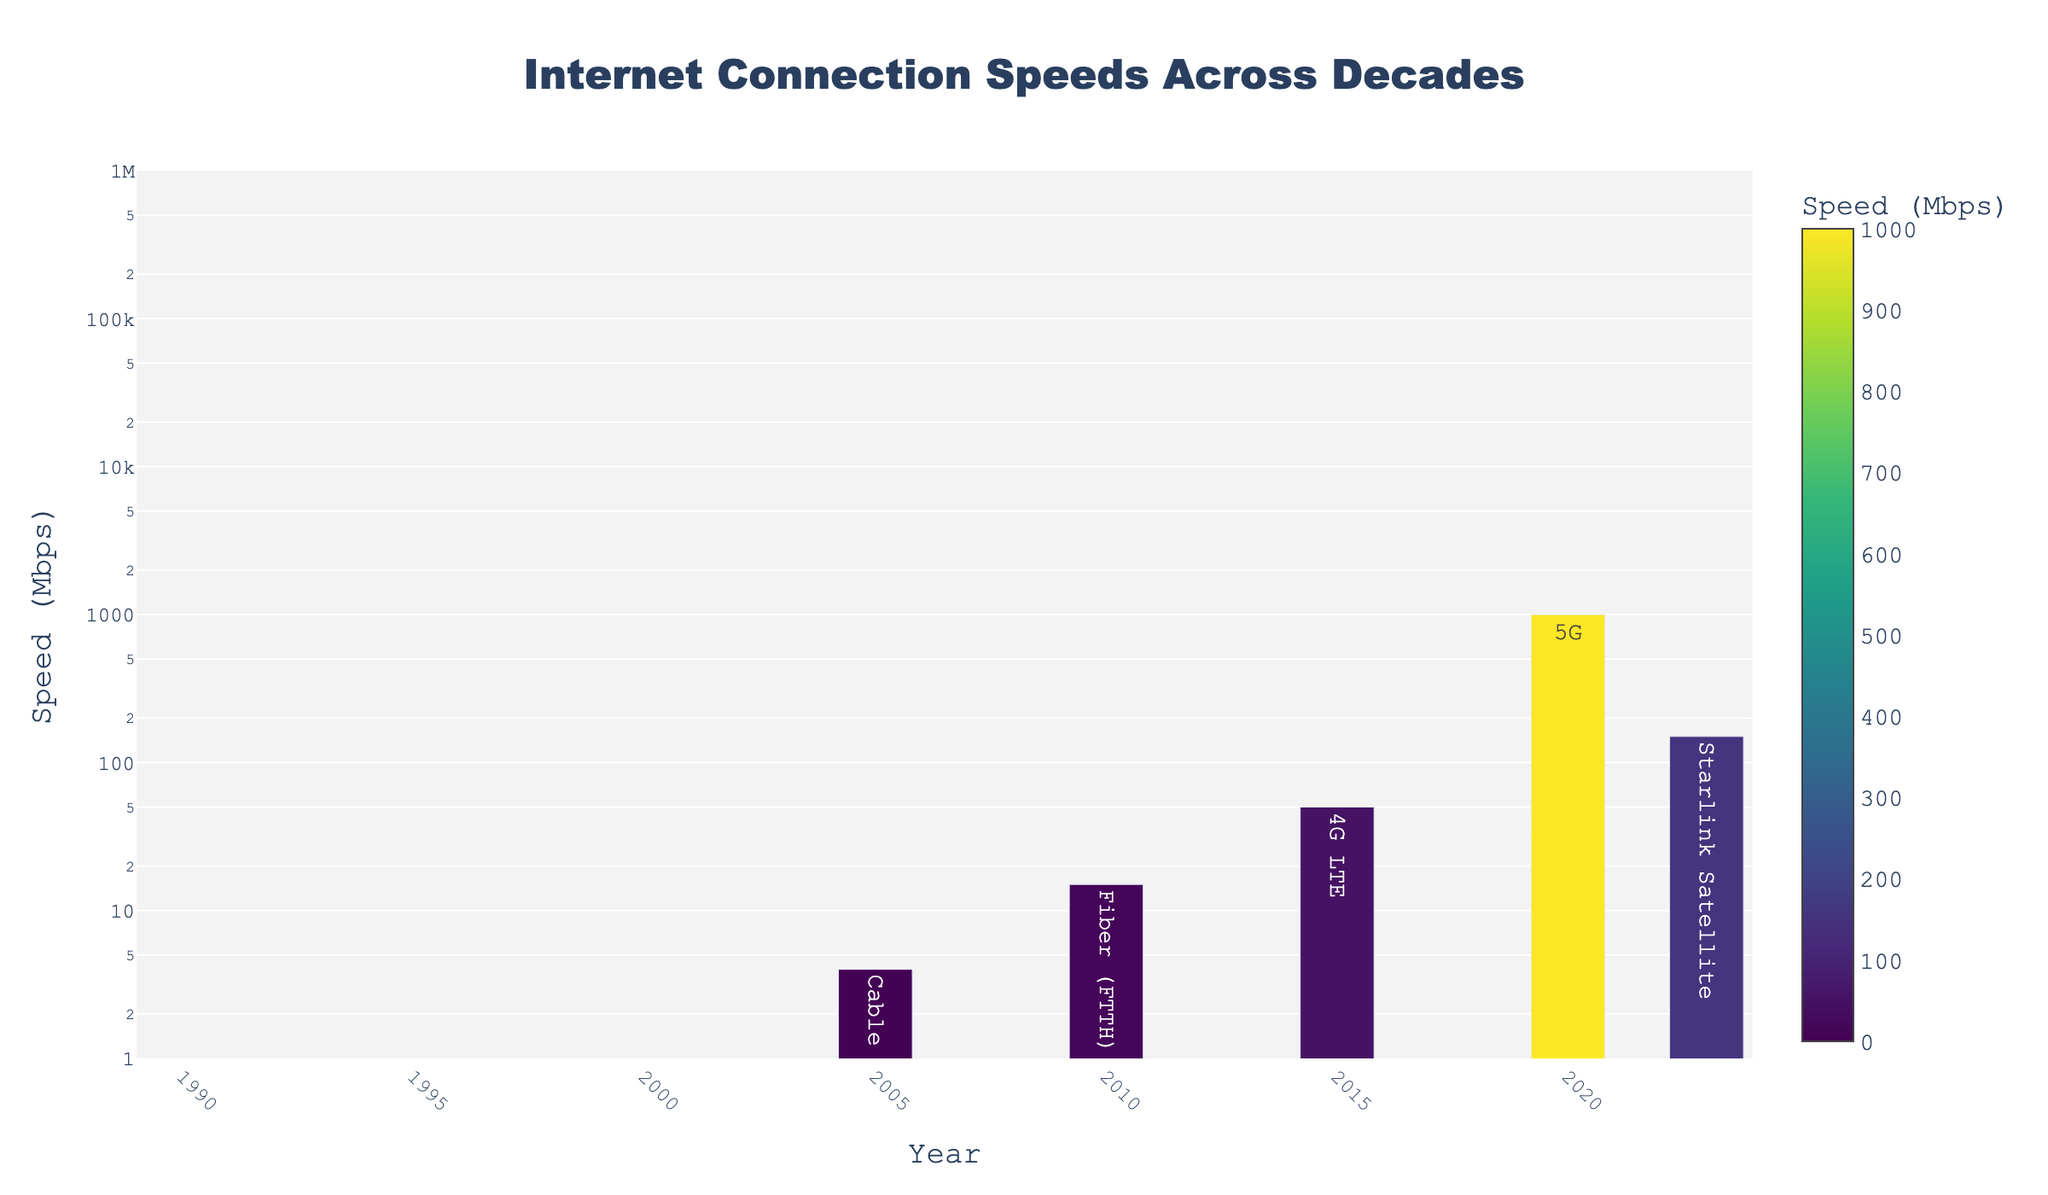What is the speed of the fastest internet connection in 2023? The bar chart has different years on the x-axis and their respective speeds on the y-axis. Locate the year 2023 on the x-axis, and the height of the bar indicates the speed of the internet connection.
Answer: 150 Mbps Which internet connection type had the lowest speed in the 1990s? The x-axis of the chart represents years, including several from the 1990s, and the y-axis shows connection speeds. Find the years within the 1990s range and check their connection types and respective speeds.
Answer: Dial-up (14.4k) How much faster is 5G in 2020 compared to Dial-up (28.8k) in 1995? Locate the speed of 5G in 2020 and Dial-up (28.8k) in 1995 on the chart. Subtract the speed of Dial-up (28.8k) from the speed of 5G.
Answer: 1000 - 0.0288 ≈ 999.9712 Mbps Which year experienced the highest percentage increase in internet speed compared to the previous recorded year? To calculate the percentage increase, you need to find the difference in speeds between consecutive years and divide by the speed of the earlier year, then multiply by 100. Check each pair of consecutive years in the chart to find the highest percentage increase.
Answer: From 2015 (50 Mbps) to 2020 (1000 Mbps), which is (1000 - 50) / 50 * 100 = 1900% Between 2000 and 2010, by what factor did the internet speed increase? Identify the years 2000 and 2010 on the x-axis, and note their respective speeds. The factor increase is calculated by dividing the speed in 2010 by the speed in 2000.
Answer: 15000 / 256 ≈ 58.59 Does the bar representing 5G in 2020 have a different color intensity compared to the others, and why? The color of the bars represents the speed in Mbps, with a color scale attached to the chart. Since 5G has the highest speed, its bar will have the most intense color.
Answer: Yes, it has the most intense color What is the median internet speed in Mbps from the given data? To find the median, list all the speeds in Mbps in ascending order: 0.0144, 0.0288, 0.064, 0.256, 4, 15, 50, 1000, 150. The median is the middle value in this ordered list.
Answer: 4 Mbps How many times faster is the internet speed in 2023 compared to ISDN in 1998? Identify the internet speed for 2023 and 1998 from the chart, then divide the speed in 2023 by the speed in 1998.
Answer: 150 / 0.064 = 2343.75 What color does the bar representing Fiber (FTTH) in 2010 have, and what does it signify about its speed? Check the color scale in the chart, and locate the year 2010. Match the color of the bar to the color scale to determine what speed range it represents.
Answer: Medium yellow to green, signifying moderate speed (15 Mbps) Between 2000 and 2005, how many orders of magnitude did the internet speed increase? Identify the speeds in 2000 (256 Kbps) and 2005 (4000 Kbps). Orders of magnitude are calculated using the logarithm base 10 of the ratio of the two speeds.
Answer: log10(4000 / 256) ≈ 1.19 